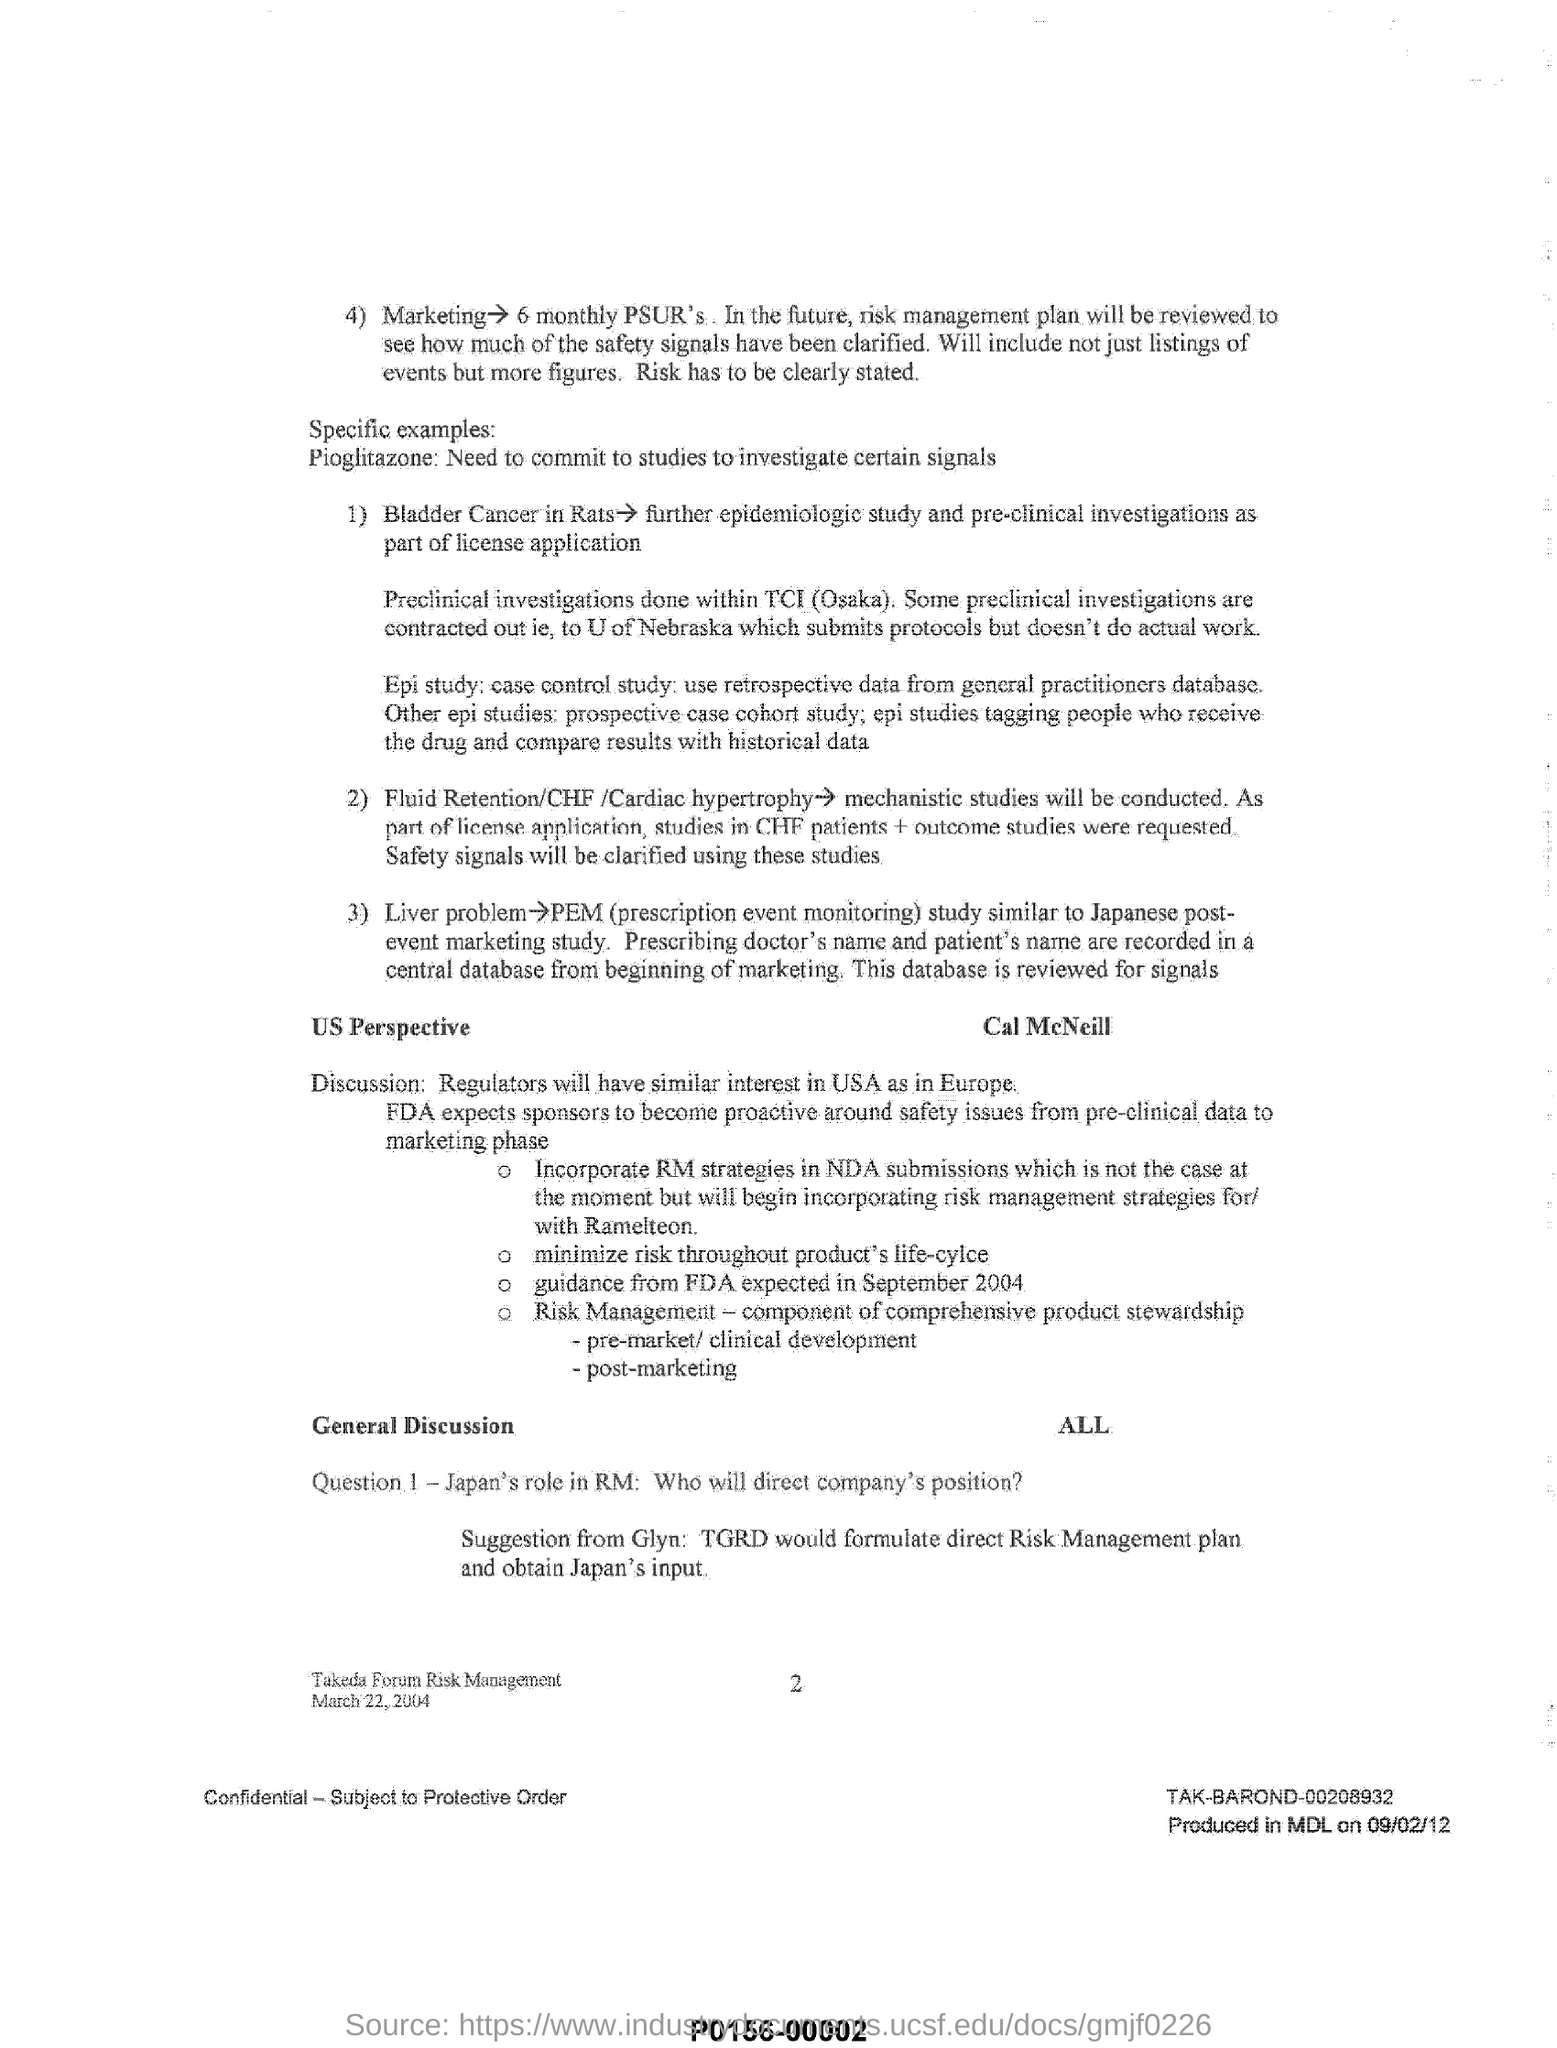Indicate a few pertinent items in this graphic. The United States of America is a country that shares similar interests with Europe. Prescription Event Monitoring" is commonly referred to as "PEM. It is suggested by Glyn that TGRD should formulate a direct risk management plan and obtain the input of Japan. Pioglitazone, a medication used to treat type 2 diabetes, requires further investigation into certain signals, as specified in the specific example. 